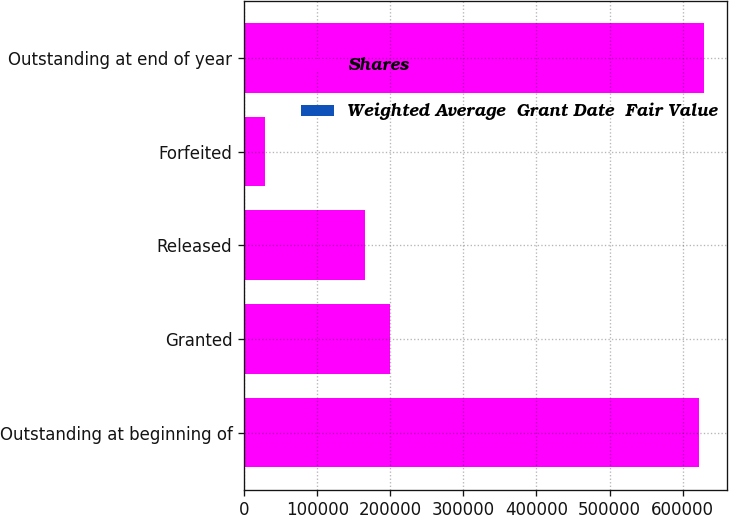Convert chart to OTSL. <chart><loc_0><loc_0><loc_500><loc_500><stacked_bar_chart><ecel><fcel>Outstanding at beginning of<fcel>Granted<fcel>Released<fcel>Forfeited<fcel>Outstanding at end of year<nl><fcel>Shares<fcel>622814<fcel>199629<fcel>165846<fcel>27955<fcel>628642<nl><fcel>Weighted Average  Grant Date  Fair Value<fcel>70.19<fcel>98.9<fcel>75.9<fcel>72.81<fcel>77.7<nl></chart> 